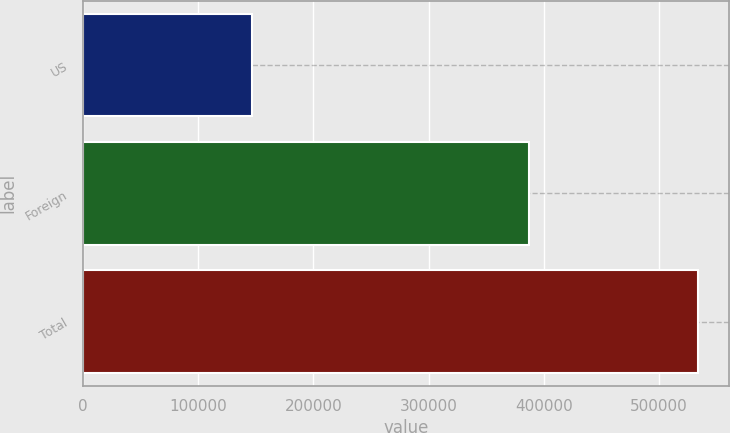Convert chart. <chart><loc_0><loc_0><loc_500><loc_500><bar_chart><fcel>US<fcel>Foreign<fcel>Total<nl><fcel>146855<fcel>387540<fcel>534395<nl></chart> 